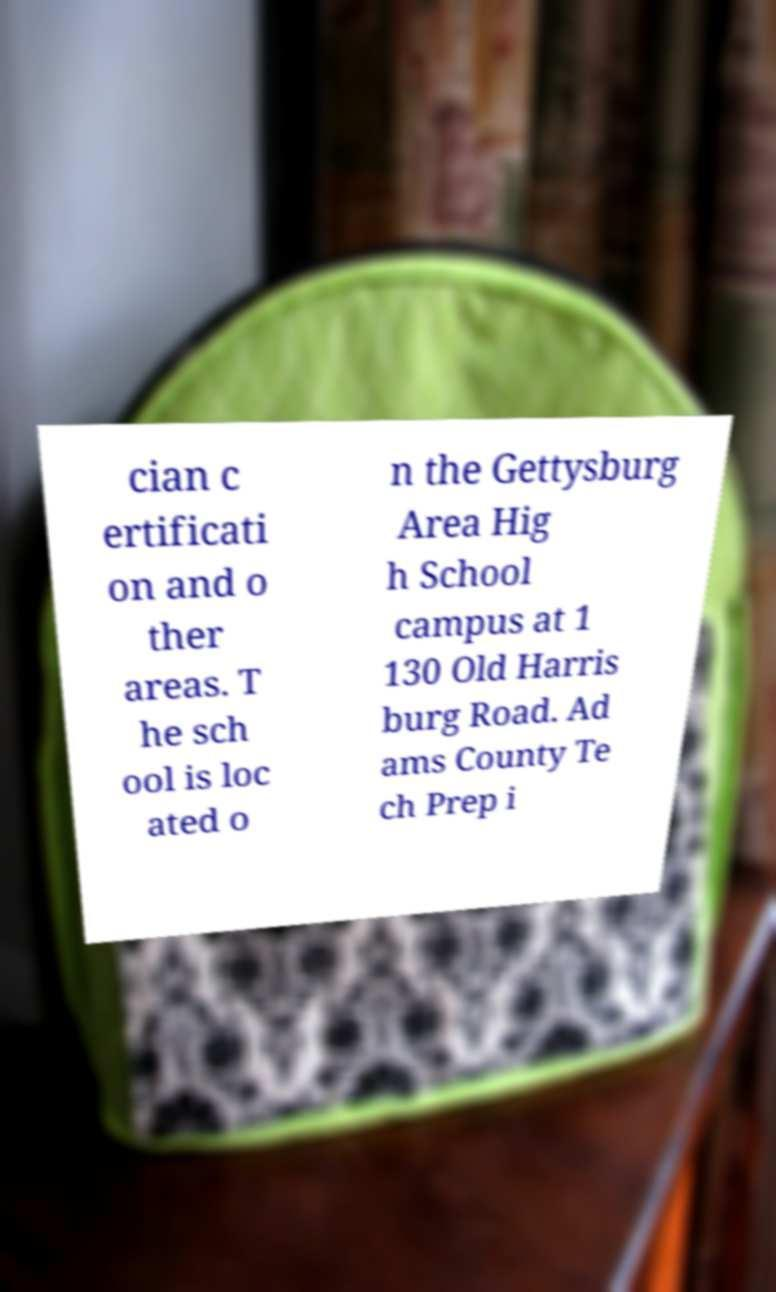Could you extract and type out the text from this image? cian c ertificati on and o ther areas. T he sch ool is loc ated o n the Gettysburg Area Hig h School campus at 1 130 Old Harris burg Road. Ad ams County Te ch Prep i 